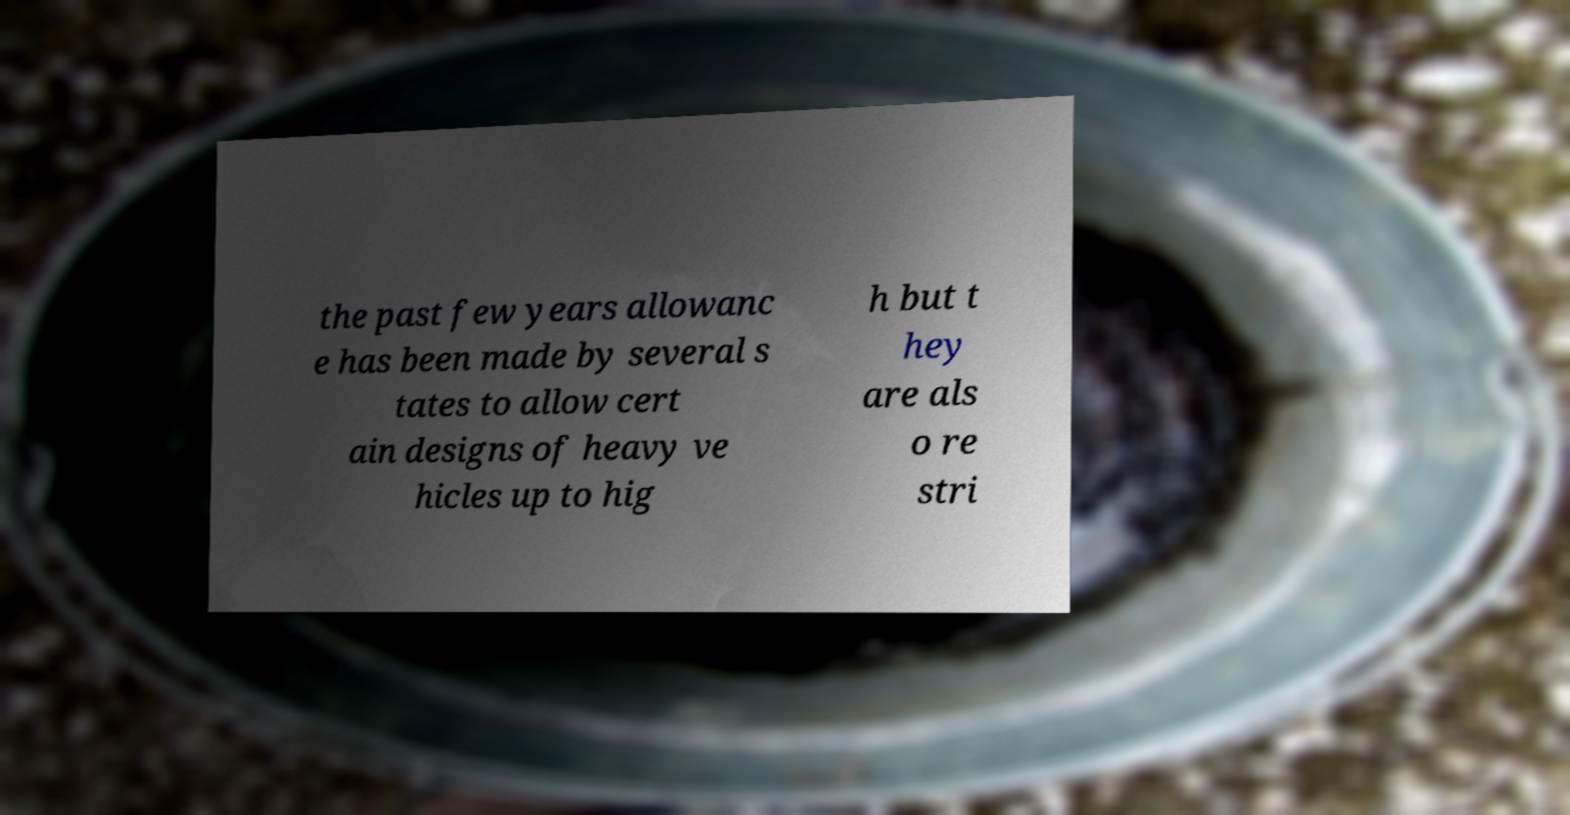What messages or text are displayed in this image? I need them in a readable, typed format. the past few years allowanc e has been made by several s tates to allow cert ain designs of heavy ve hicles up to hig h but t hey are als o re stri 